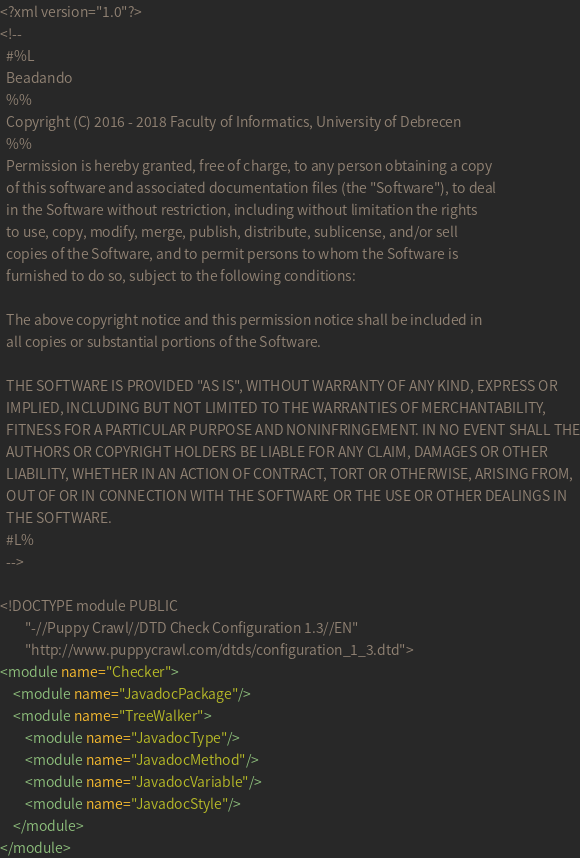Convert code to text. <code><loc_0><loc_0><loc_500><loc_500><_XML_><?xml version="1.0"?>
<!--
  #%L
  Beadando
  %%
  Copyright (C) 2016 - 2018 Faculty of Informatics, University of Debrecen
  %%
  Permission is hereby granted, free of charge, to any person obtaining a copy
  of this software and associated documentation files (the "Software"), to deal
  in the Software without restriction, including without limitation the rights
  to use, copy, modify, merge, publish, distribute, sublicense, and/or sell
  copies of the Software, and to permit persons to whom the Software is
  furnished to do so, subject to the following conditions:
  
  The above copyright notice and this permission notice shall be included in
  all copies or substantial portions of the Software.
  
  THE SOFTWARE IS PROVIDED "AS IS", WITHOUT WARRANTY OF ANY KIND, EXPRESS OR
  IMPLIED, INCLUDING BUT NOT LIMITED TO THE WARRANTIES OF MERCHANTABILITY,
  FITNESS FOR A PARTICULAR PURPOSE AND NONINFRINGEMENT. IN NO EVENT SHALL THE
  AUTHORS OR COPYRIGHT HOLDERS BE LIABLE FOR ANY CLAIM, DAMAGES OR OTHER
  LIABILITY, WHETHER IN AN ACTION OF CONTRACT, TORT OR OTHERWISE, ARISING FROM,
  OUT OF OR IN CONNECTION WITH THE SOFTWARE OR THE USE OR OTHER DEALINGS IN
  THE SOFTWARE.
  #L%
  -->

<!DOCTYPE module PUBLIC
        "-//Puppy Crawl//DTD Check Configuration 1.3//EN"
        "http://www.puppycrawl.com/dtds/configuration_1_3.dtd">
<module name="Checker">
    <module name="JavadocPackage"/>
    <module name="TreeWalker">
        <module name="JavadocType"/>
        <module name="JavadocMethod"/>
        <module name="JavadocVariable"/>
        <module name="JavadocStyle"/>
    </module>
</module>
</code> 